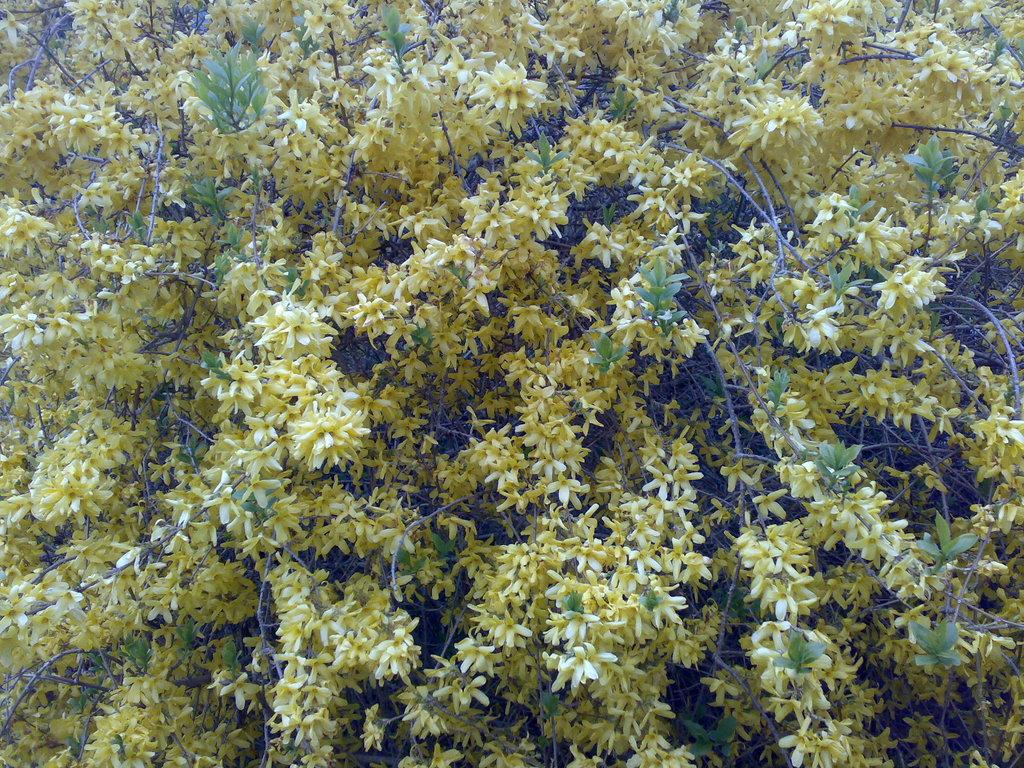What is the main subject of the picture? The main subject of the picture is a tree. What can be seen on the tree? There are yellow flowers on the tree. What else is visible on the tree besides the flowers? There are branches and leaves on the tree. What type of loaf can be seen hanging from the tree in the image? There is no loaf present in the image; it features a tree with yellow flowers, branches, and leaves. Can you see any basketball players in the image? There are no basketball players or any reference to a basketball game in the image. 